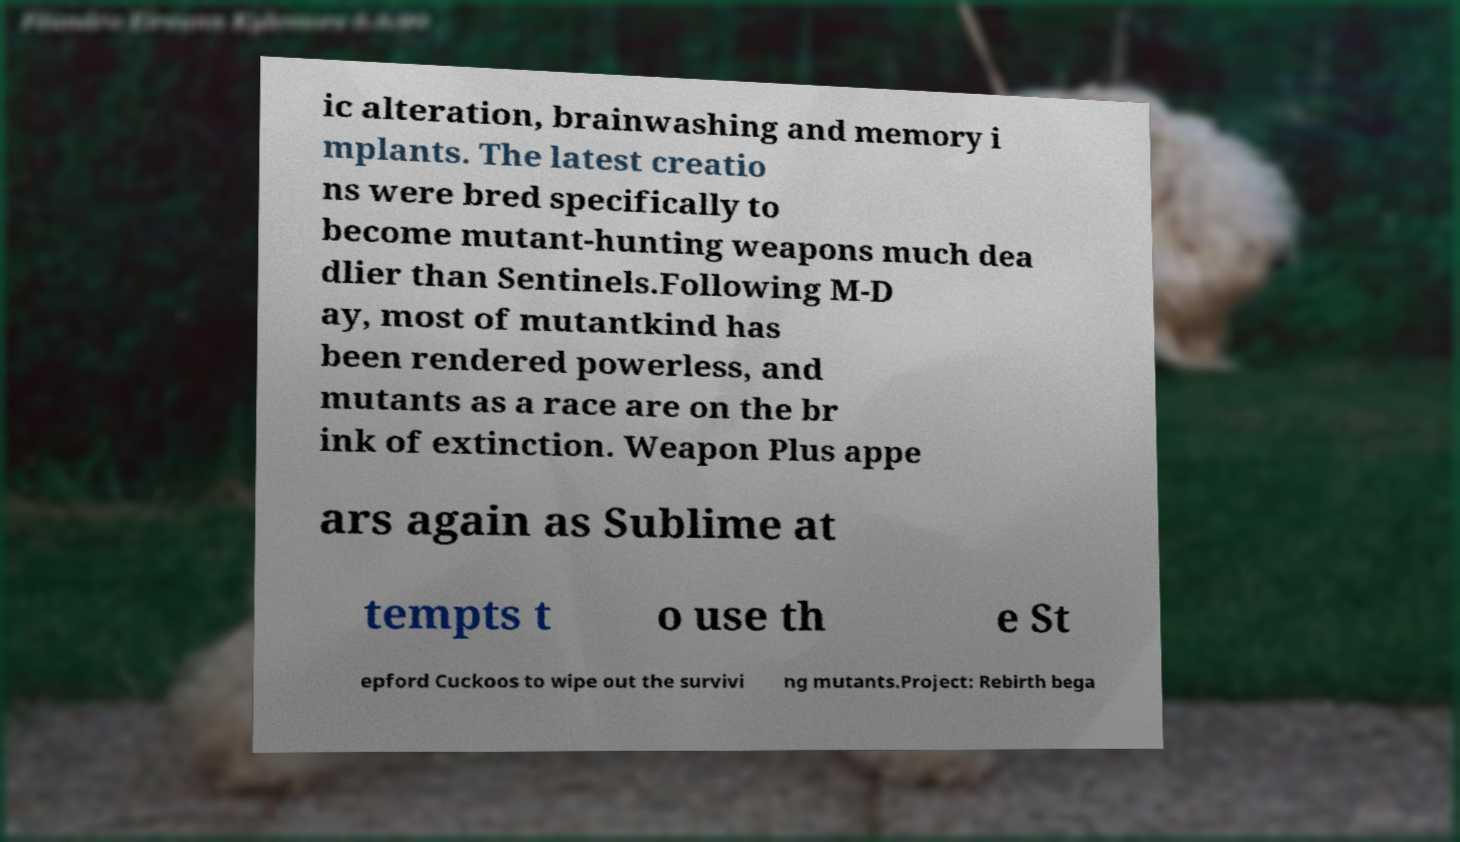For documentation purposes, I need the text within this image transcribed. Could you provide that? ic alteration, brainwashing and memory i mplants. The latest creatio ns were bred specifically to become mutant-hunting weapons much dea dlier than Sentinels.Following M-D ay, most of mutantkind has been rendered powerless, and mutants as a race are on the br ink of extinction. Weapon Plus appe ars again as Sublime at tempts t o use th e St epford Cuckoos to wipe out the survivi ng mutants.Project: Rebirth bega 